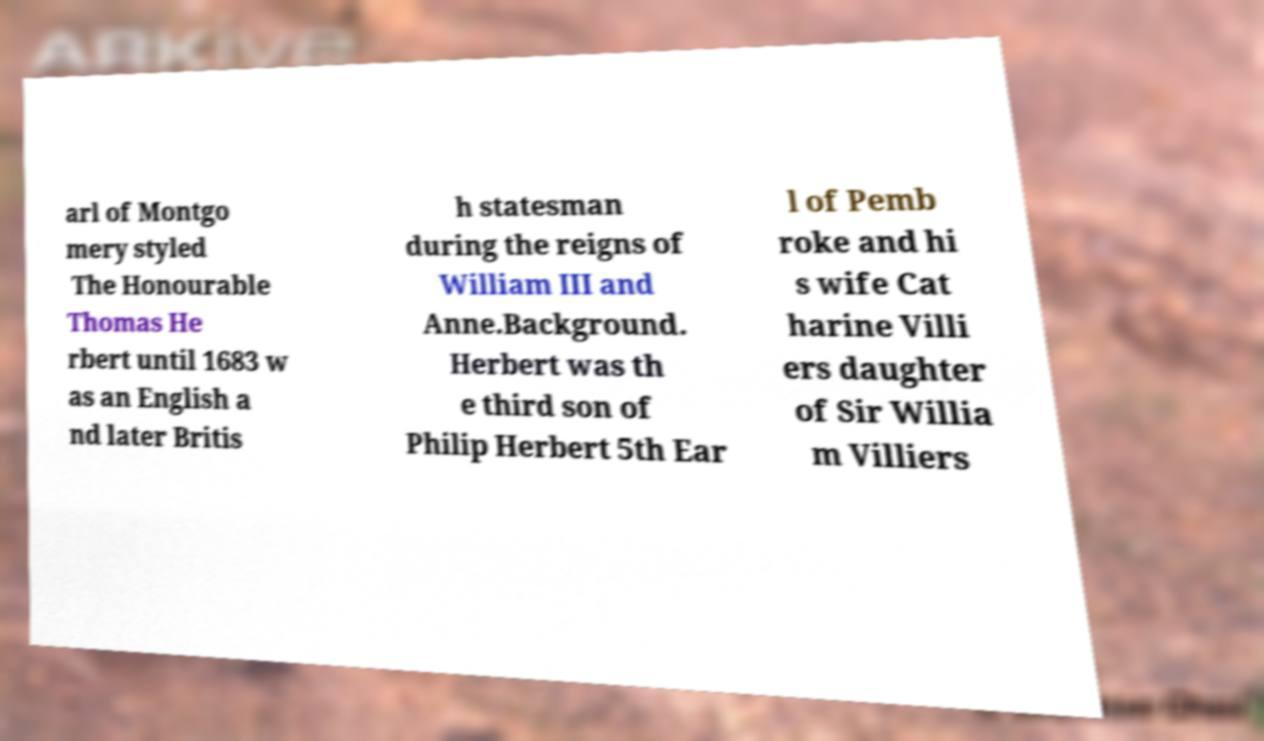What messages or text are displayed in this image? I need them in a readable, typed format. arl of Montgo mery styled The Honourable Thomas He rbert until 1683 w as an English a nd later Britis h statesman during the reigns of William III and Anne.Background. Herbert was th e third son of Philip Herbert 5th Ear l of Pemb roke and hi s wife Cat harine Villi ers daughter of Sir Willia m Villiers 